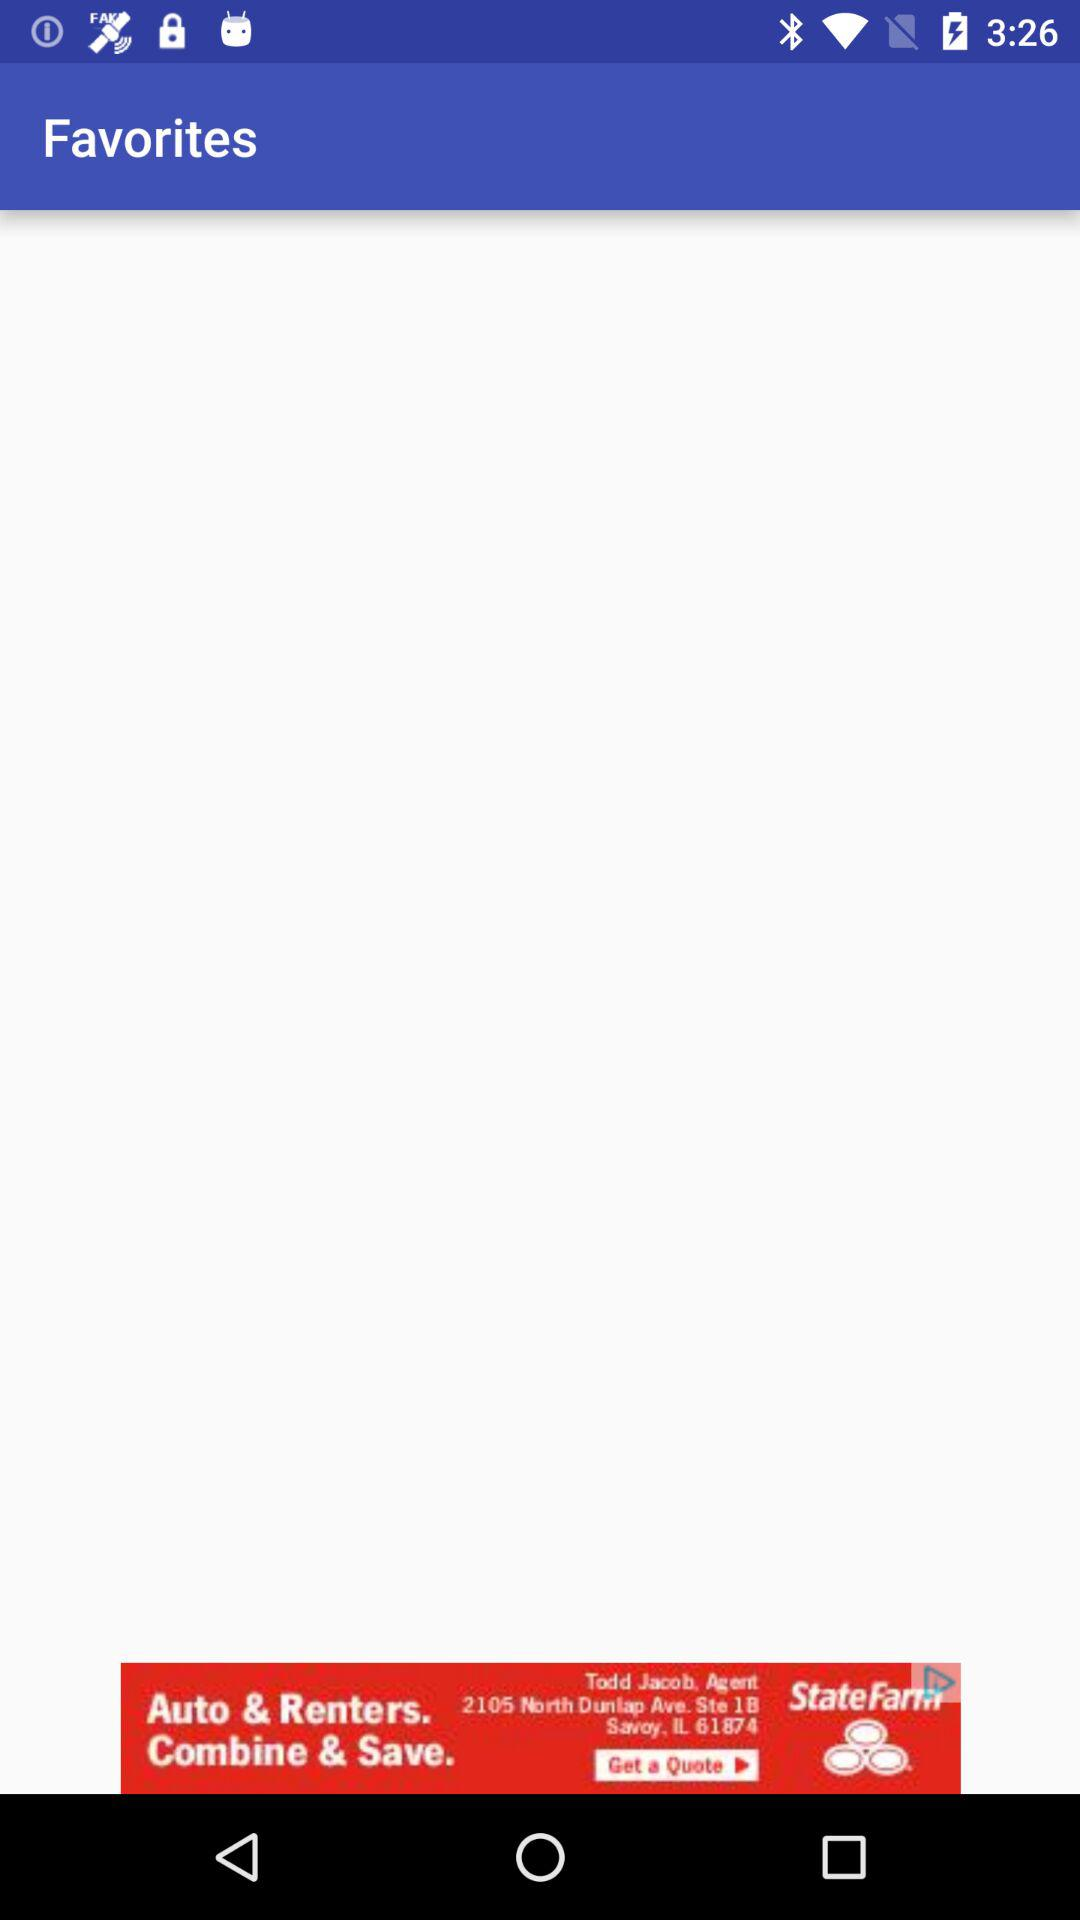Which tab is selected? The selected tab is "TUTORIALS". 